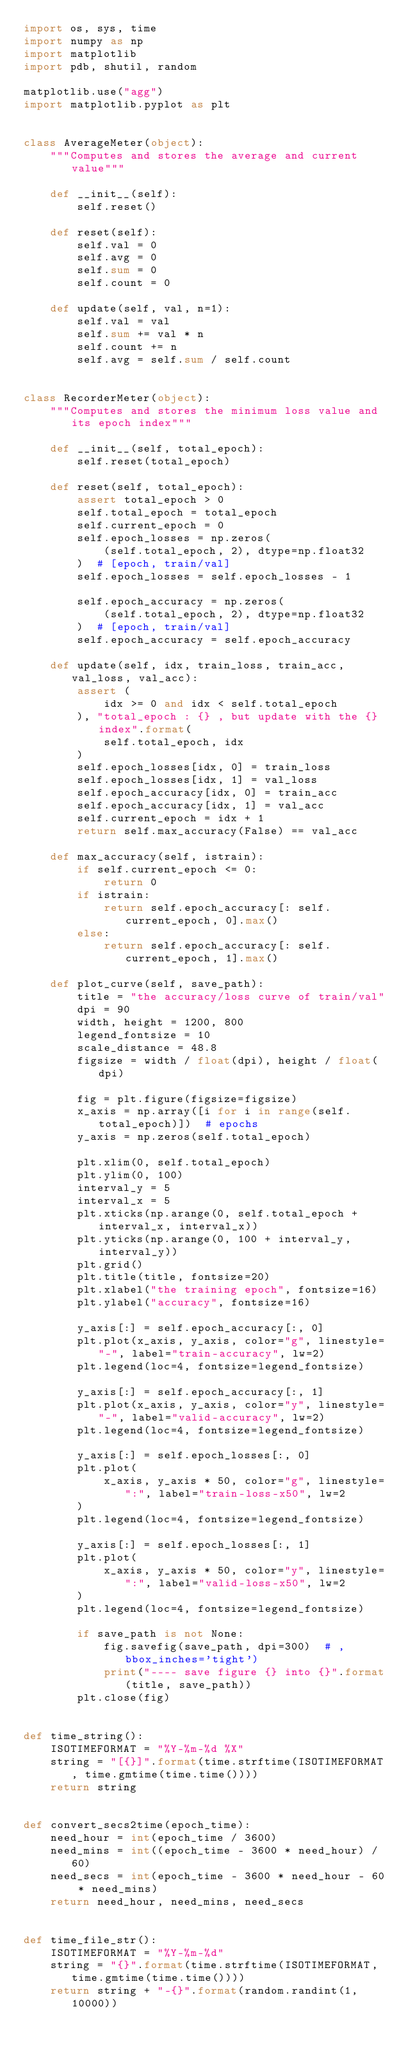Convert code to text. <code><loc_0><loc_0><loc_500><loc_500><_Python_>import os, sys, time
import numpy as np
import matplotlib
import pdb, shutil, random

matplotlib.use("agg")
import matplotlib.pyplot as plt


class AverageMeter(object):
    """Computes and stores the average and current value"""

    def __init__(self):
        self.reset()

    def reset(self):
        self.val = 0
        self.avg = 0
        self.sum = 0
        self.count = 0

    def update(self, val, n=1):
        self.val = val
        self.sum += val * n
        self.count += n
        self.avg = self.sum / self.count


class RecorderMeter(object):
    """Computes and stores the minimum loss value and its epoch index"""

    def __init__(self, total_epoch):
        self.reset(total_epoch)

    def reset(self, total_epoch):
        assert total_epoch > 0
        self.total_epoch = total_epoch
        self.current_epoch = 0
        self.epoch_losses = np.zeros(
            (self.total_epoch, 2), dtype=np.float32
        )  # [epoch, train/val]
        self.epoch_losses = self.epoch_losses - 1

        self.epoch_accuracy = np.zeros(
            (self.total_epoch, 2), dtype=np.float32
        )  # [epoch, train/val]
        self.epoch_accuracy = self.epoch_accuracy

    def update(self, idx, train_loss, train_acc, val_loss, val_acc):
        assert (
            idx >= 0 and idx < self.total_epoch
        ), "total_epoch : {} , but update with the {} index".format(
            self.total_epoch, idx
        )
        self.epoch_losses[idx, 0] = train_loss
        self.epoch_losses[idx, 1] = val_loss
        self.epoch_accuracy[idx, 0] = train_acc
        self.epoch_accuracy[idx, 1] = val_acc
        self.current_epoch = idx + 1
        return self.max_accuracy(False) == val_acc

    def max_accuracy(self, istrain):
        if self.current_epoch <= 0:
            return 0
        if istrain:
            return self.epoch_accuracy[: self.current_epoch, 0].max()
        else:
            return self.epoch_accuracy[: self.current_epoch, 1].max()

    def plot_curve(self, save_path):
        title = "the accuracy/loss curve of train/val"
        dpi = 90
        width, height = 1200, 800
        legend_fontsize = 10
        scale_distance = 48.8
        figsize = width / float(dpi), height / float(dpi)

        fig = plt.figure(figsize=figsize)
        x_axis = np.array([i for i in range(self.total_epoch)])  # epochs
        y_axis = np.zeros(self.total_epoch)

        plt.xlim(0, self.total_epoch)
        plt.ylim(0, 100)
        interval_y = 5
        interval_x = 5
        plt.xticks(np.arange(0, self.total_epoch + interval_x, interval_x))
        plt.yticks(np.arange(0, 100 + interval_y, interval_y))
        plt.grid()
        plt.title(title, fontsize=20)
        plt.xlabel("the training epoch", fontsize=16)
        plt.ylabel("accuracy", fontsize=16)

        y_axis[:] = self.epoch_accuracy[:, 0]
        plt.plot(x_axis, y_axis, color="g", linestyle="-", label="train-accuracy", lw=2)
        plt.legend(loc=4, fontsize=legend_fontsize)

        y_axis[:] = self.epoch_accuracy[:, 1]
        plt.plot(x_axis, y_axis, color="y", linestyle="-", label="valid-accuracy", lw=2)
        plt.legend(loc=4, fontsize=legend_fontsize)

        y_axis[:] = self.epoch_losses[:, 0]
        plt.plot(
            x_axis, y_axis * 50, color="g", linestyle=":", label="train-loss-x50", lw=2
        )
        plt.legend(loc=4, fontsize=legend_fontsize)

        y_axis[:] = self.epoch_losses[:, 1]
        plt.plot(
            x_axis, y_axis * 50, color="y", linestyle=":", label="valid-loss-x50", lw=2
        )
        plt.legend(loc=4, fontsize=legend_fontsize)

        if save_path is not None:
            fig.savefig(save_path, dpi=300)  # , bbox_inches='tight')
            print("---- save figure {} into {}".format(title, save_path))
        plt.close(fig)


def time_string():
    ISOTIMEFORMAT = "%Y-%m-%d %X"
    string = "[{}]".format(time.strftime(ISOTIMEFORMAT, time.gmtime(time.time())))
    return string


def convert_secs2time(epoch_time):
    need_hour = int(epoch_time / 3600)
    need_mins = int((epoch_time - 3600 * need_hour) / 60)
    need_secs = int(epoch_time - 3600 * need_hour - 60 * need_mins)
    return need_hour, need_mins, need_secs


def time_file_str():
    ISOTIMEFORMAT = "%Y-%m-%d"
    string = "{}".format(time.strftime(ISOTIMEFORMAT, time.gmtime(time.time())))
    return string + "-{}".format(random.randint(1, 10000))
</code> 